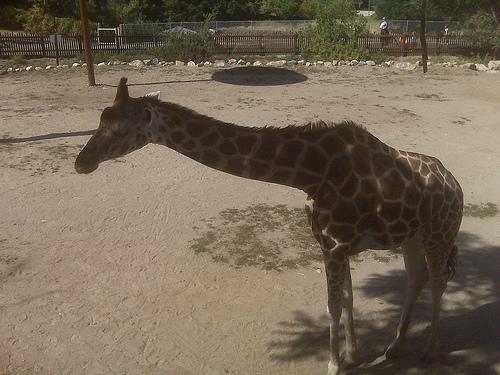How many giraffes are there?
Give a very brief answer. 1. 